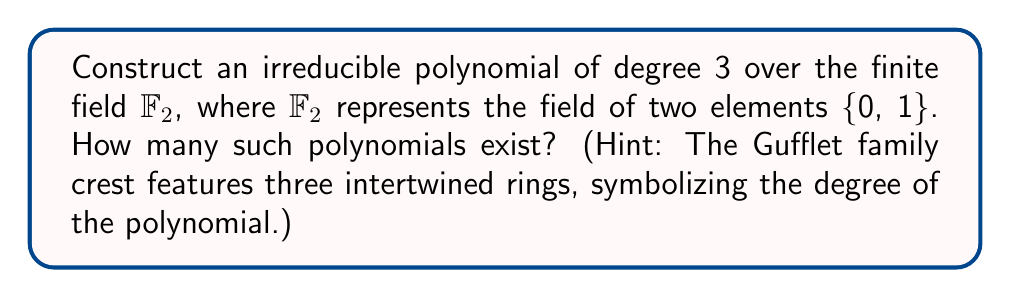Provide a solution to this math problem. Let's approach this step-by-step:

1) First, we need to understand what polynomials of degree 3 over $\mathbb{F}_2$ look like:
   $$f(x) = ax^3 + bx^2 + cx + d$$
   where $a, b, c, d \in \mathbb{F}_2 = \{0, 1\}$ and $a \neq 0$.

2) Since $a$ must be 1 (as it can't be 0), we have 8 possible polynomials:
   $$x^3 + bx^2 + cx + d$$
   where $b, c, d \in \{0, 1\}$

3) To determine which of these are irreducible, we need to check if they have any roots in $\mathbb{F}_2$. A polynomial is irreducible over $\mathbb{F}_2$ if and only if it has no roots in $\mathbb{F}_2$.

4) Let's check each possible polynomial:

   - $x^3 + 0x^2 + 0x + 0 = x^3$: Reducible (has root 0)
   - $x^3 + 0x^2 + 0x + 1 = x^3 + 1$: Irreducible
   - $x^3 + 0x^2 + x + 0 = x^3 + x$: Reducible (has root 0)
   - $x^3 + 0x^2 + x + 1 = x^3 + x + 1$: Irreducible
   - $x^3 + x^2 + 0x + 0 = x^3 + x^2$: Reducible (has root 0)
   - $x^3 + x^2 + 0x + 1 = x^3 + x^2 + 1$: Irreducible
   - $x^3 + x^2 + x + 0 = x^3 + x^2 + x$: Reducible (has root 1)
   - $x^3 + x^2 + x + 1 = x^3 + x^2 + x + 1$: Irreducible

5) Therefore, there are 4 irreducible polynomials of degree 3 over $\mathbb{F}_2$:
   $$x^3 + 1, \quad x^3 + x + 1, \quad x^3 + x^2 + 1, \quad x^3 + x^2 + x + 1$$
Answer: 4 